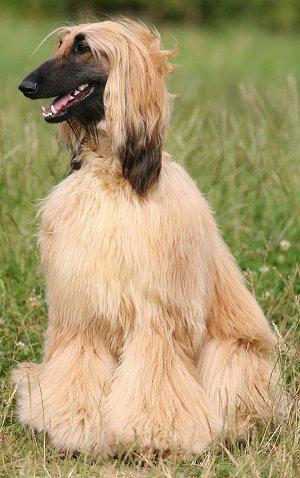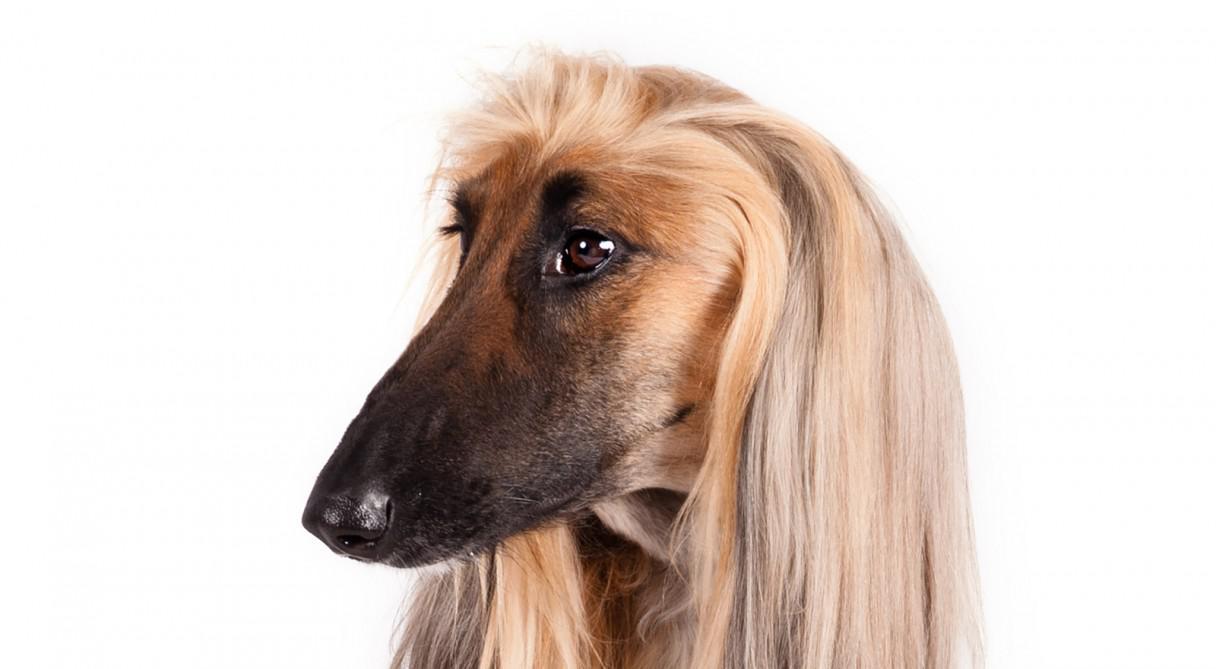The first image is the image on the left, the second image is the image on the right. Evaluate the accuracy of this statement regarding the images: "At least one image shows a hound on all fours on the grassy ground.". Is it true? Answer yes or no. No. 